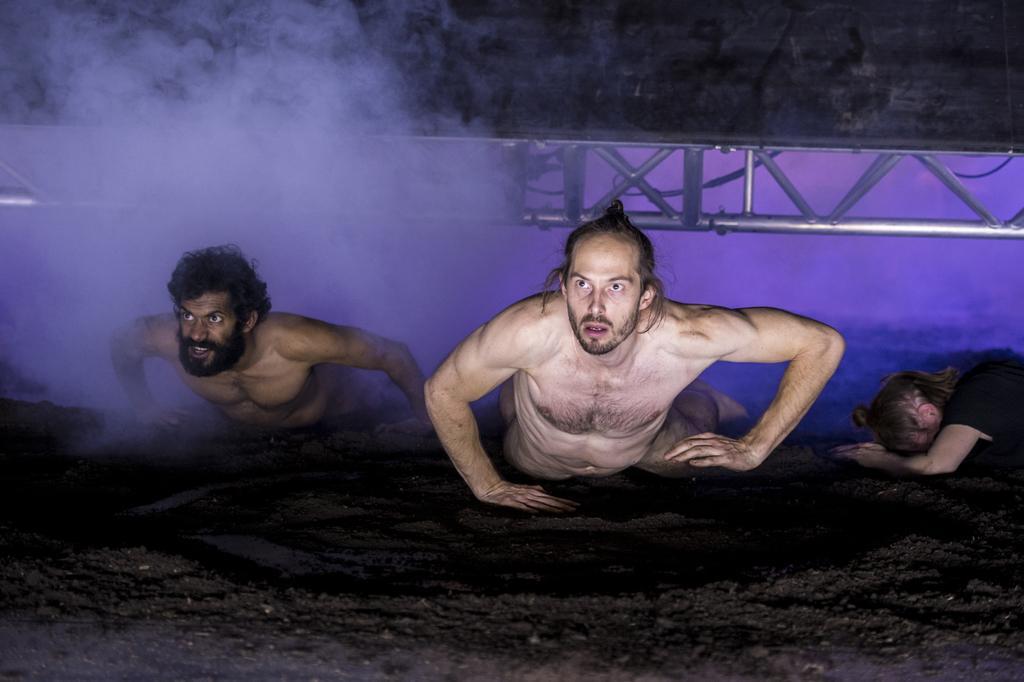In one or two sentences, can you explain what this image depicts? In this image, we can see three people on the surface. In the background we can see smoke, rods, wires and some object. 